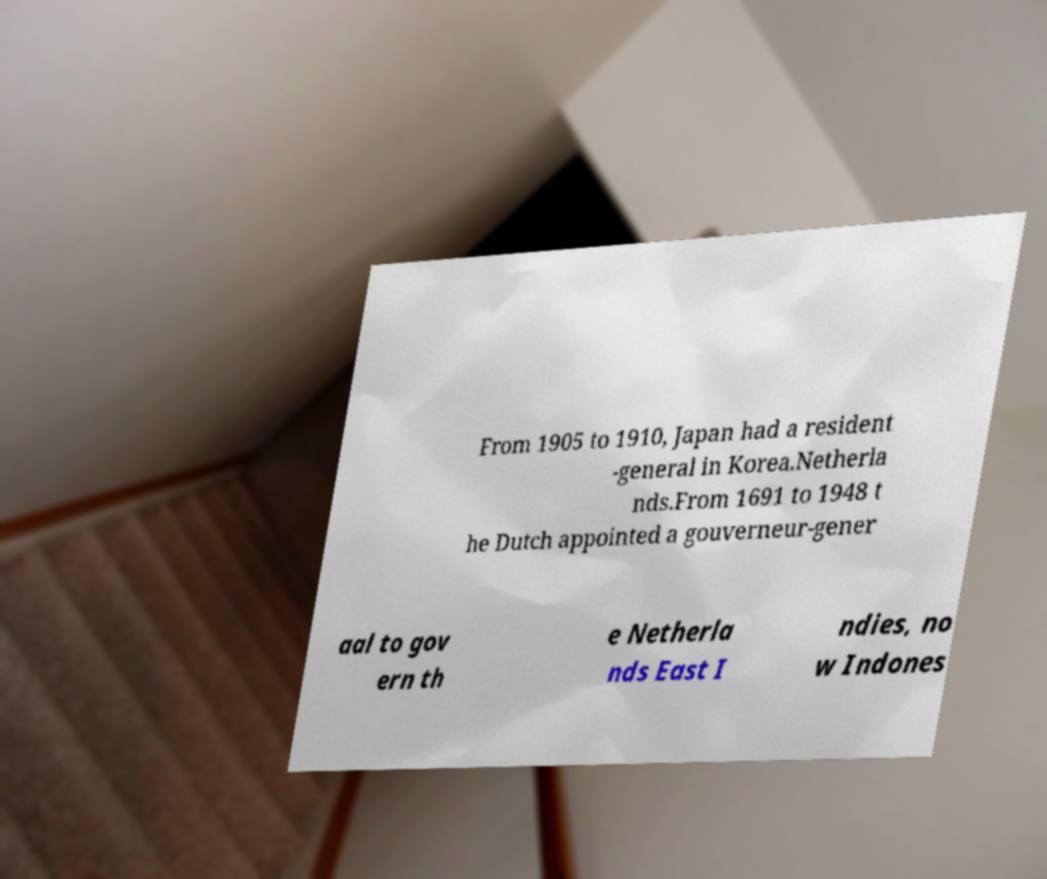Can you read and provide the text displayed in the image?This photo seems to have some interesting text. Can you extract and type it out for me? From 1905 to 1910, Japan had a resident -general in Korea.Netherla nds.From 1691 to 1948 t he Dutch appointed a gouverneur-gener aal to gov ern th e Netherla nds East I ndies, no w Indones 